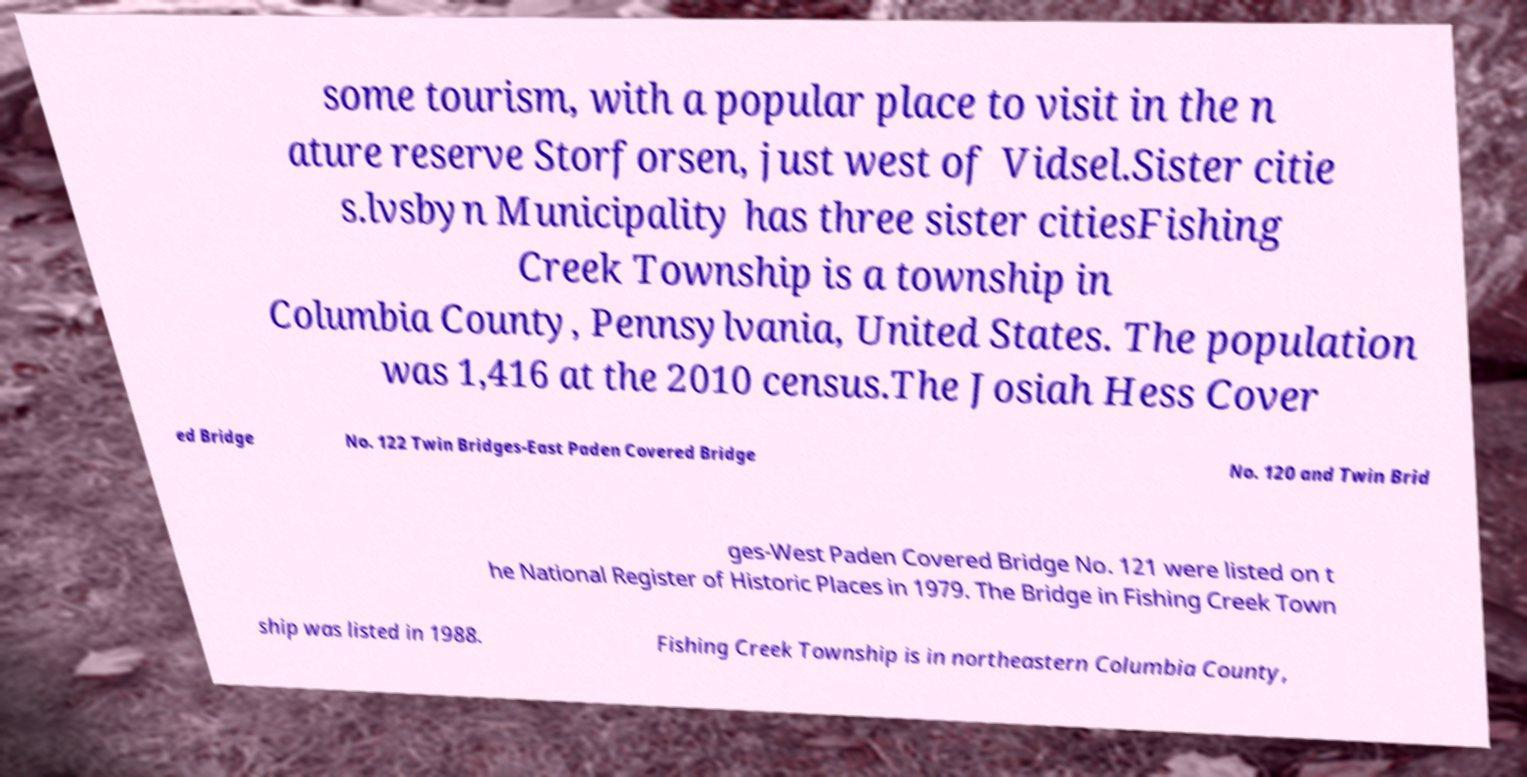Can you read and provide the text displayed in the image?This photo seems to have some interesting text. Can you extract and type it out for me? some tourism, with a popular place to visit in the n ature reserve Storforsen, just west of Vidsel.Sister citie s.lvsbyn Municipality has three sister citiesFishing Creek Township is a township in Columbia County, Pennsylvania, United States. The population was 1,416 at the 2010 census.The Josiah Hess Cover ed Bridge No. 122 Twin Bridges-East Paden Covered Bridge No. 120 and Twin Brid ges-West Paden Covered Bridge No. 121 were listed on t he National Register of Historic Places in 1979. The Bridge in Fishing Creek Town ship was listed in 1988. Fishing Creek Township is in northeastern Columbia County, 